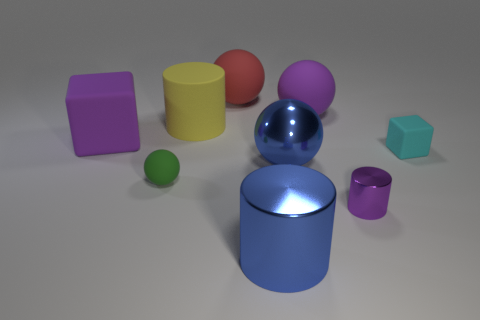Are there any yellow cylinders of the same size as the cyan rubber block? No, there are no yellow cylinders that match the size of the cyan block in the image. The yellow object present is a cylinder, but it has a distinctly smaller diameter compared to the cyan block's side length. 